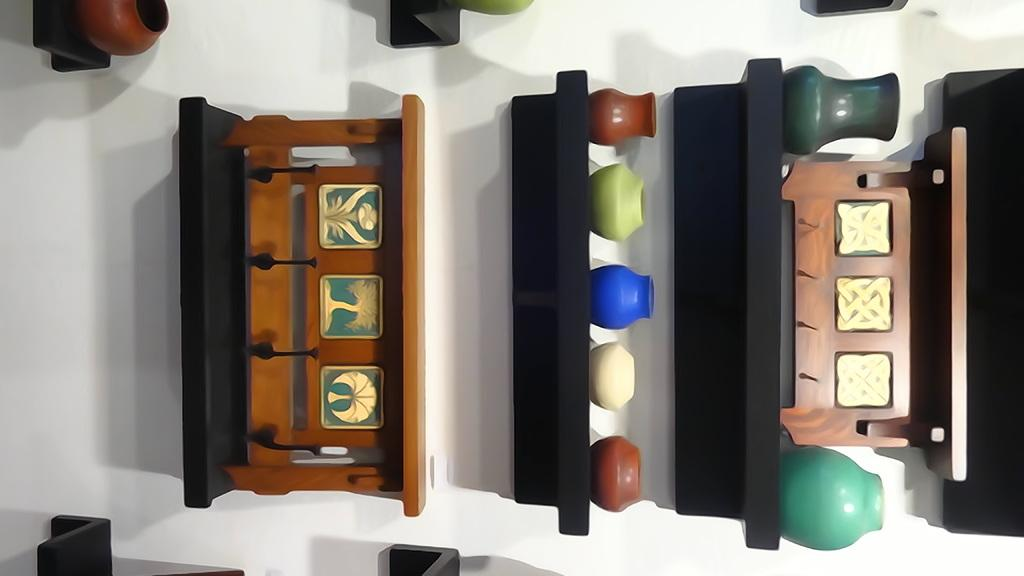What type of furniture is present in the image? There are shelves in the image. What can be found on the shelves? The shelves have crockery items on them. How are the shelves positioned in the image? The shelves are attached to the wall. Is there a volcano erupting in the background of the image? No, there is no volcano present in the image. 